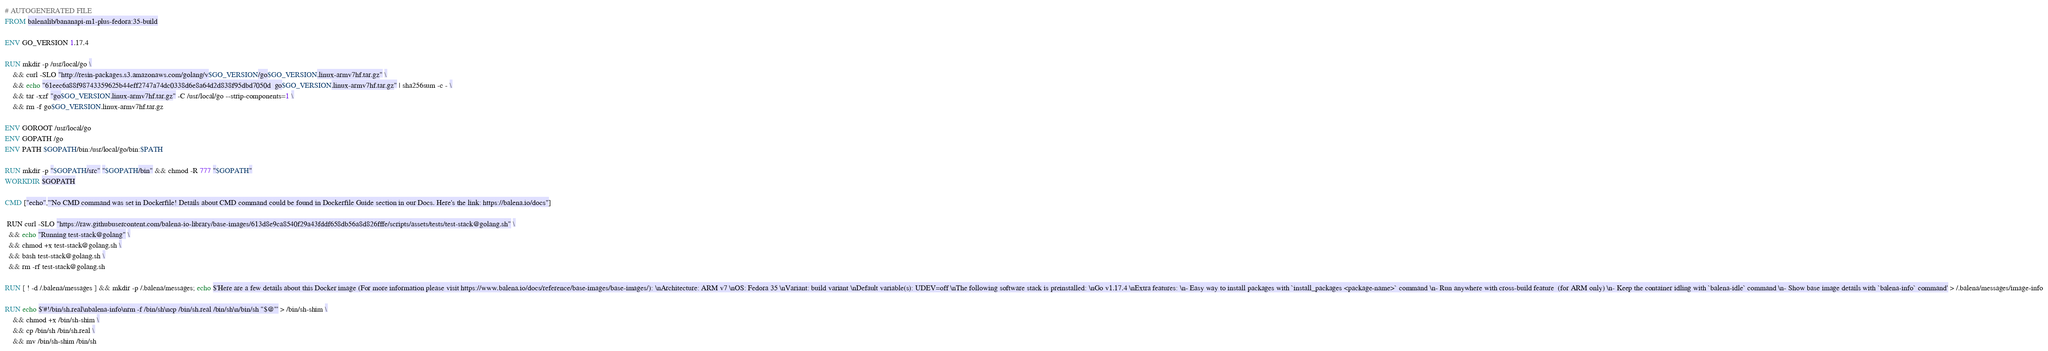Convert code to text. <code><loc_0><loc_0><loc_500><loc_500><_Dockerfile_># AUTOGENERATED FILE
FROM balenalib/bananapi-m1-plus-fedora:35-build

ENV GO_VERSION 1.17.4

RUN mkdir -p /usr/local/go \
	&& curl -SLO "http://resin-packages.s3.amazonaws.com/golang/v$GO_VERSION/go$GO_VERSION.linux-armv7hf.tar.gz" \
	&& echo "61eec6a88f98743359625b44eff2747a74dc0338d6e8a64d2d838f95dbd7050d  go$GO_VERSION.linux-armv7hf.tar.gz" | sha256sum -c - \
	&& tar -xzf "go$GO_VERSION.linux-armv7hf.tar.gz" -C /usr/local/go --strip-components=1 \
	&& rm -f go$GO_VERSION.linux-armv7hf.tar.gz

ENV GOROOT /usr/local/go
ENV GOPATH /go
ENV PATH $GOPATH/bin:/usr/local/go/bin:$PATH

RUN mkdir -p "$GOPATH/src" "$GOPATH/bin" && chmod -R 777 "$GOPATH"
WORKDIR $GOPATH

CMD ["echo","'No CMD command was set in Dockerfile! Details about CMD command could be found in Dockerfile Guide section in our Docs. Here's the link: https://balena.io/docs"]

 RUN curl -SLO "https://raw.githubusercontent.com/balena-io-library/base-images/613d8e9ca8540f29a43fddf658db56a8d826fffe/scripts/assets/tests/test-stack@golang.sh" \
  && echo "Running test-stack@golang" \
  && chmod +x test-stack@golang.sh \
  && bash test-stack@golang.sh \
  && rm -rf test-stack@golang.sh 

RUN [ ! -d /.balena/messages ] && mkdir -p /.balena/messages; echo $'Here are a few details about this Docker image (For more information please visit https://www.balena.io/docs/reference/base-images/base-images/): \nArchitecture: ARM v7 \nOS: Fedora 35 \nVariant: build variant \nDefault variable(s): UDEV=off \nThe following software stack is preinstalled: \nGo v1.17.4 \nExtra features: \n- Easy way to install packages with `install_packages <package-name>` command \n- Run anywhere with cross-build feature  (for ARM only) \n- Keep the container idling with `balena-idle` command \n- Show base image details with `balena-info` command' > /.balena/messages/image-info

RUN echo $'#!/bin/sh.real\nbalena-info\nrm -f /bin/sh\ncp /bin/sh.real /bin/sh\n/bin/sh "$@"' > /bin/sh-shim \
	&& chmod +x /bin/sh-shim \
	&& cp /bin/sh /bin/sh.real \
	&& mv /bin/sh-shim /bin/sh</code> 